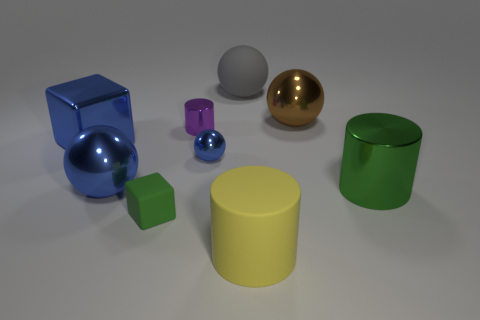There is a large sphere in front of the brown sphere; does it have the same color as the big block?
Your answer should be very brief. Yes. There is a thing that is the same color as the tiny block; what is it made of?
Offer a terse response. Metal. What is the size of the matte cube that is the same color as the big shiny cylinder?
Your answer should be very brief. Small. Does the metal cylinder that is to the right of the large gray sphere have the same color as the cube that is right of the large cube?
Your answer should be compact. Yes. Are there any big cylinders of the same color as the small block?
Your answer should be very brief. Yes. Is there any other thing that has the same color as the big block?
Offer a very short reply. Yes. What number of things are big gray rubber cylinders or big objects that are on the right side of the small cylinder?
Your answer should be compact. 4. The cylinder that is right of the large cylinder left of the green object that is behind the small block is what color?
Offer a terse response. Green. There is a large gray object that is the same shape as the small blue shiny object; what is it made of?
Your response must be concise. Rubber. The tiny block has what color?
Your answer should be compact. Green. 